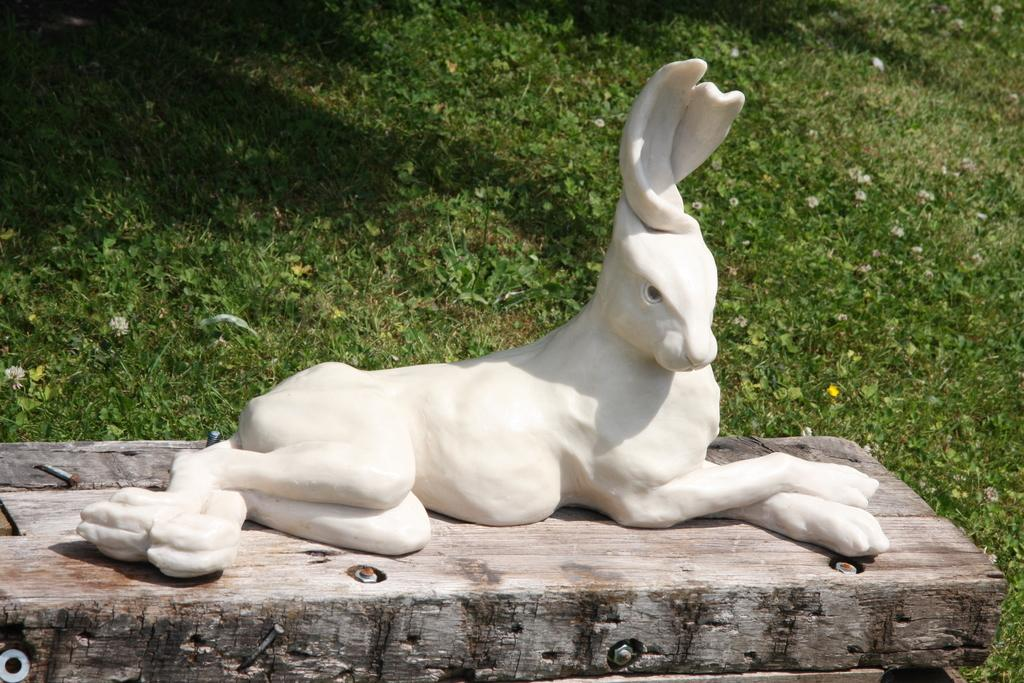What is the main subject in the image? There is a statue in the image. What is the statue standing on? The statue is on a wooden platform. What type of vegetation can be seen at the bottom of the image? There is grass visible at the bottom of the image. What type of trousers is the statue wearing in the image? The statue is not a living being and therefore does not wear trousers. The statue is made of a material like stone or metal and is not dressed in clothing. 